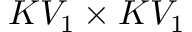<formula> <loc_0><loc_0><loc_500><loc_500>K V _ { 1 } \times K V _ { 1 }</formula> 